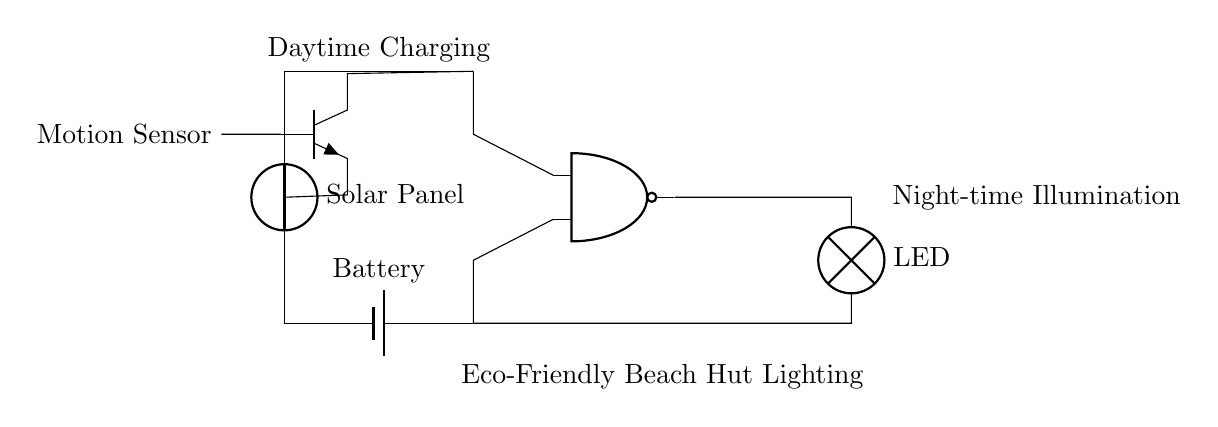What is the main function of the NAND gate in this circuit? The NAND gate operates as a logic gate that outputs a low signal only when both of its inputs are high. In this circuit, it controls the LED lighting based on the input signals from the solar panel and motion sensor.
Answer: controls LED lighting How many inputs does the NAND gate have? The NAND gate in the circuit has two inputs, which are connected to the battery and motion sensor outputs.
Answer: two inputs What component powers the LED when it’s dark? The LED is powered by the battery that stores energy from the solar panel during the day, allowing it to light up at night when needed.
Answer: battery What triggers the NAND gate to turn on the LED? The NAND gate is triggered by the motion sensor, which detects movement, resulting in the gate outputting a high signal to turn on the LED.
Answer: motion sensor What is the primary energy source for this circuit? The primary energy source for this circuit is the solar panel that provides power during the day for charging the battery.
Answer: solar panel What happens to the LED output when both inputs of the NAND gate are high? When both inputs of the NAND gate are high, the output will be low, hence the LED will not illuminate. This is a critical function as it conserves energy during conditions that don't require lighting.
Answer: not illuminate 